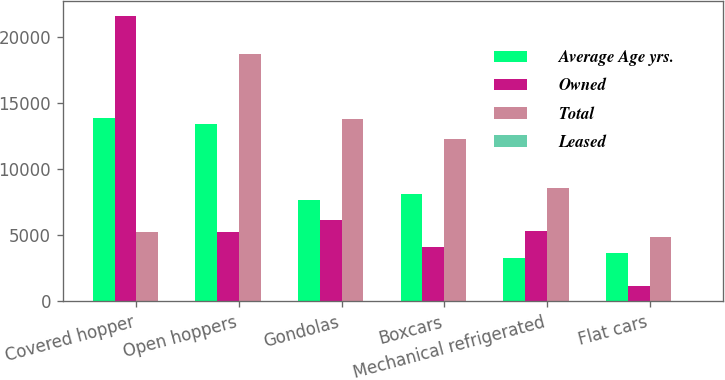<chart> <loc_0><loc_0><loc_500><loc_500><stacked_bar_chart><ecel><fcel>Covered hopper<fcel>Open hoppers<fcel>Gondolas<fcel>Boxcars<fcel>Mechanical refrigerated<fcel>Flat cars<nl><fcel>Average Age yrs.<fcel>13864<fcel>13431<fcel>7639<fcel>8132<fcel>3309<fcel>3687<nl><fcel>Owned<fcel>21573<fcel>5216<fcel>6141<fcel>4140<fcel>5291<fcel>1149<nl><fcel>Total<fcel>5216<fcel>18647<fcel>13780<fcel>12272<fcel>8600<fcel>4836<nl><fcel>Leased<fcel>28.7<fcel>28.6<fcel>26.6<fcel>27.1<fcel>22.3<fcel>30.2<nl></chart> 